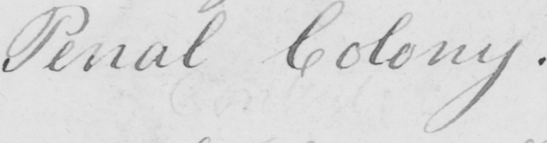Can you read and transcribe this handwriting? Penal Colony . 